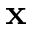<formula> <loc_0><loc_0><loc_500><loc_500>x</formula> 